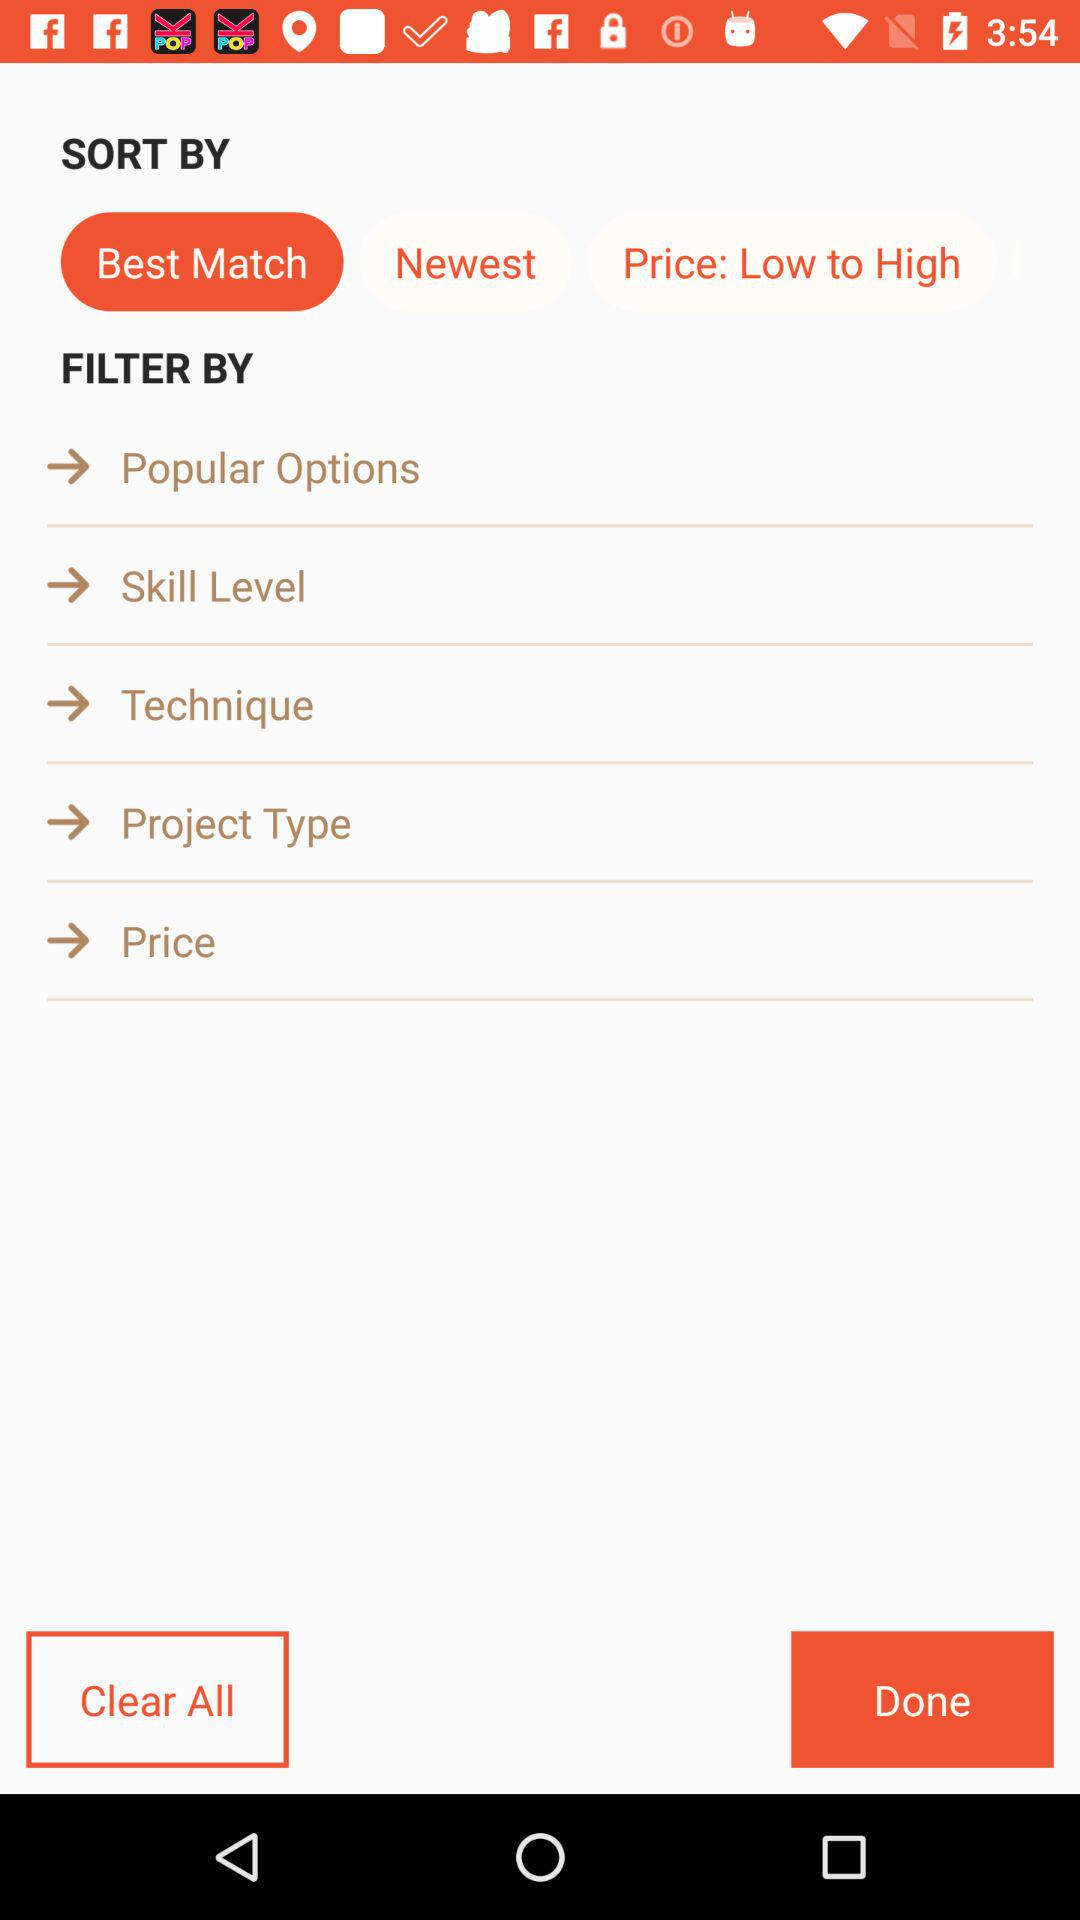What is the selected sort by? The selected sort by is "Best Match". 